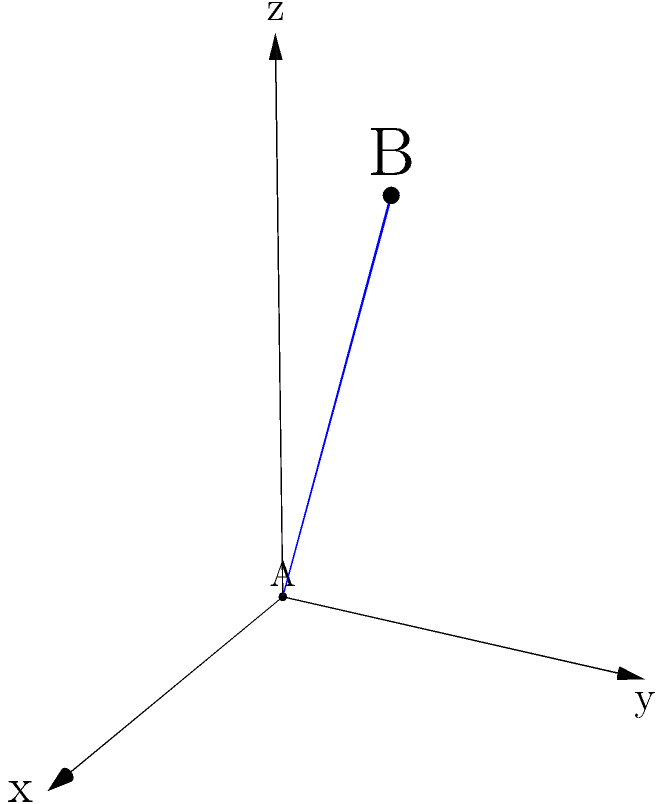Two satellites are positioned in space, with their locations given in a 3D coordinate system. Satellite A is at the origin (0, 0, 0), and Satellite B is at coordinates (4, 3, 5) kilometers. Calculate the straight-line distance between these two satellites to ensure proper data transmission and integrity for the flight systems. To calculate the distance between two points in 3D space, we use the three-dimensional distance formula, which is an extension of the Pythagorean theorem:

1. The distance formula in 3D is:
   $$d = \sqrt{(x_2-x_1)^2 + (y_2-y_1)^2 + (z_2-z_1)^2}$$

2. Given:
   Satellite A: $(x_1, y_1, z_1) = (0, 0, 0)$
   Satellite B: $(x_2, y_2, z_2) = (4, 3, 5)$

3. Substituting these values into the formula:
   $$d = \sqrt{(4-0)^2 + (3-0)^2 + (5-0)^2}$$

4. Simplify:
   $$d = \sqrt{4^2 + 3^2 + 5^2}$$

5. Calculate the squares:
   $$d = \sqrt{16 + 9 + 25}$$

6. Sum inside the square root:
   $$d = \sqrt{50}$$

7. Simplify the square root:
   $$d = 5\sqrt{2} \approx 7.071$$

Therefore, the straight-line distance between the two satellites is $5\sqrt{2}$ kilometers or approximately 7.071 kilometers.
Answer: $5\sqrt{2}$ km 